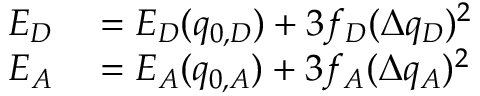<formula> <loc_0><loc_0><loc_500><loc_500>\begin{array} { r l } { E _ { D } } & = E _ { D } ( q _ { 0 , D } ) + 3 f _ { D } ( \Delta q _ { D } ) ^ { 2 } } \\ { E _ { A } } & = E _ { A } ( q _ { 0 , A } ) + 3 f _ { A } ( \Delta q _ { A } ) ^ { 2 } } \end{array}</formula> 